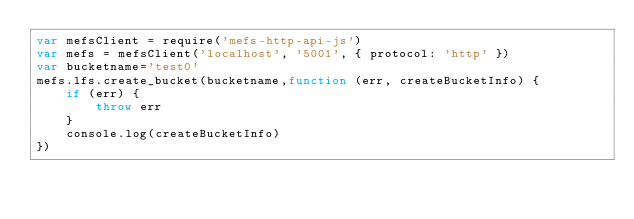<code> <loc_0><loc_0><loc_500><loc_500><_JavaScript_>var mefsClient = require('mefs-http-api-js')
var mefs = mefsClient('localhost', '5001', { protocol: 'http' })
var bucketname='test0'
mefs.lfs.create_bucket(bucketname,function (err, createBucketInfo) {
    if (err) {
        throw err
    }
    console.log(createBucketInfo)
})</code> 